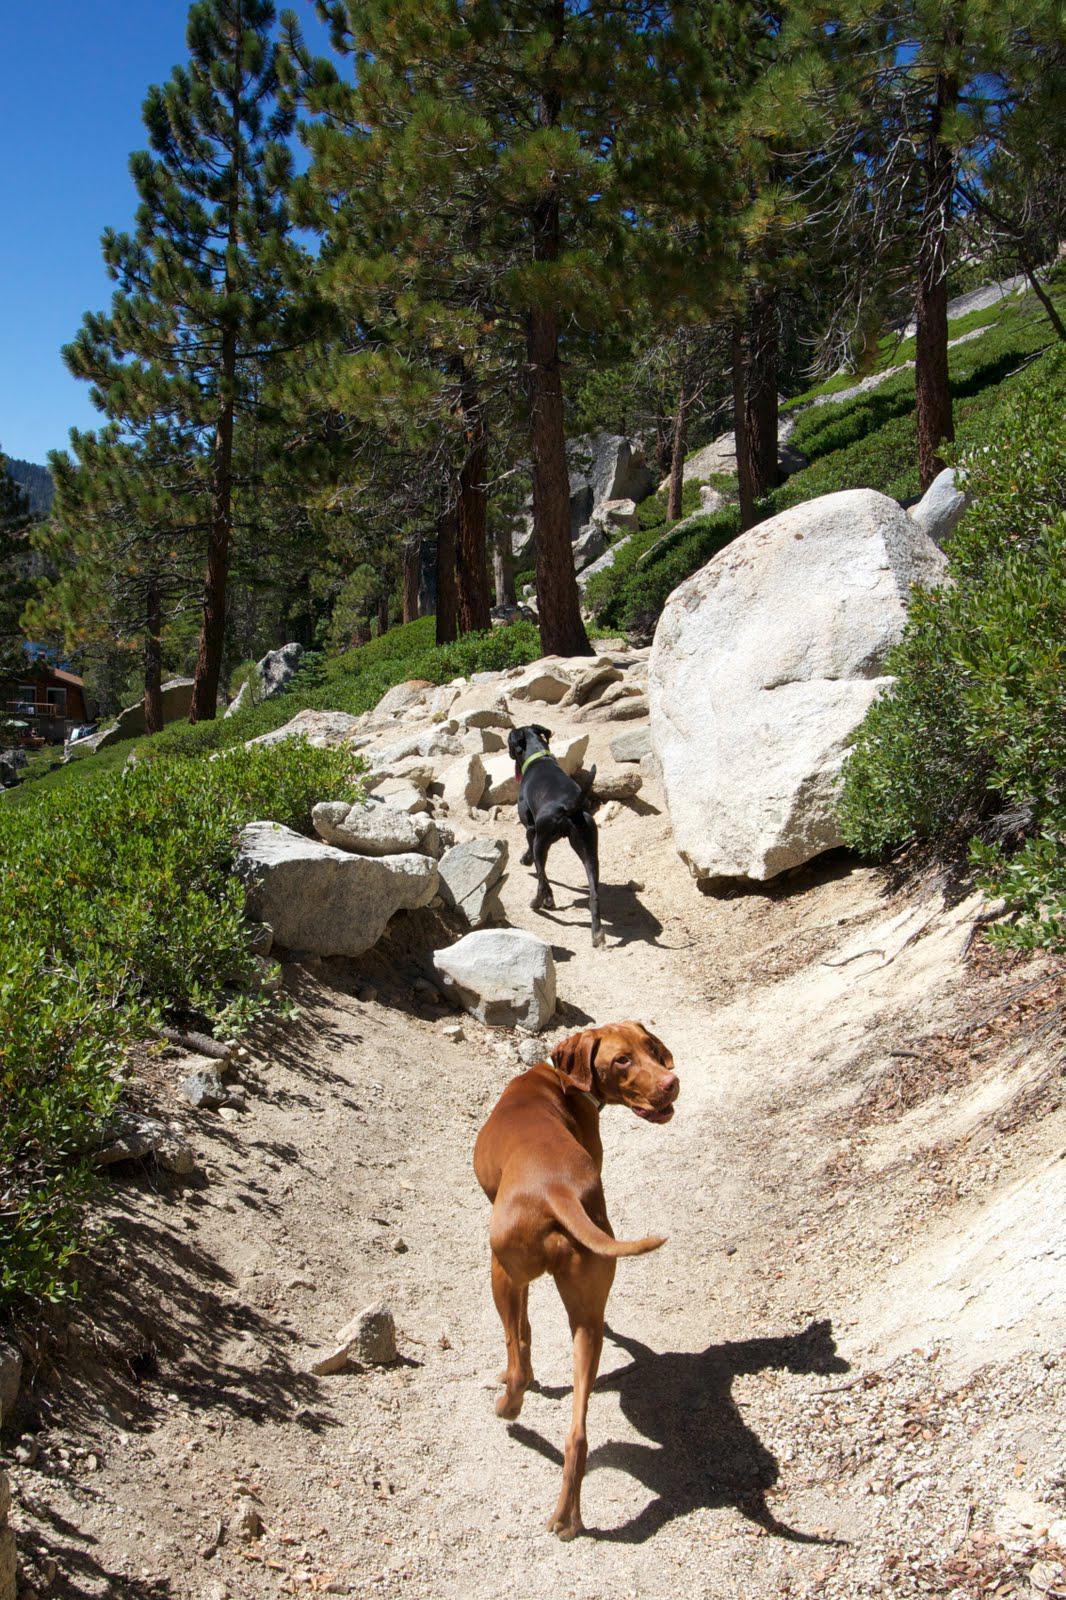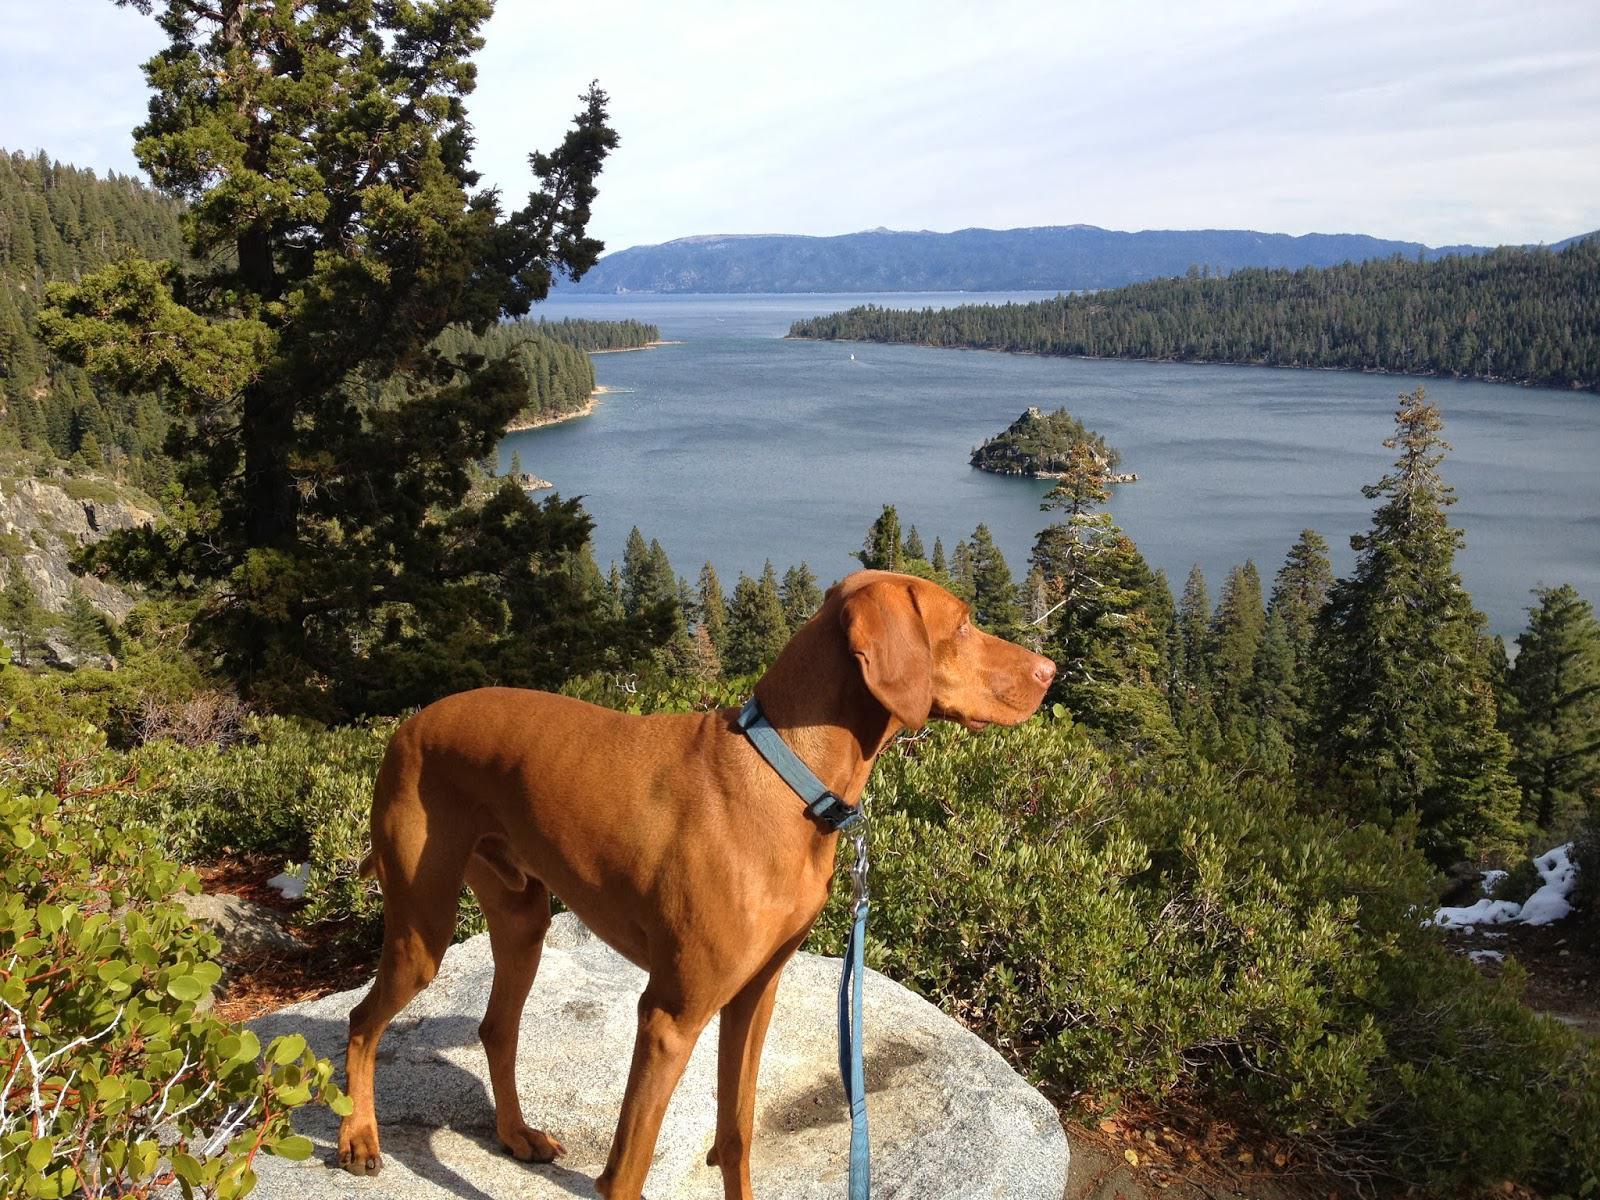The first image is the image on the left, the second image is the image on the right. Assess this claim about the two images: "There is three dogs.". Correct or not? Answer yes or no. Yes. The first image is the image on the left, the second image is the image on the right. For the images shown, is this caption "In one image, a red-orange dog in a collar with a leash attached stands on a high rock perch gazing." true? Answer yes or no. Yes. 